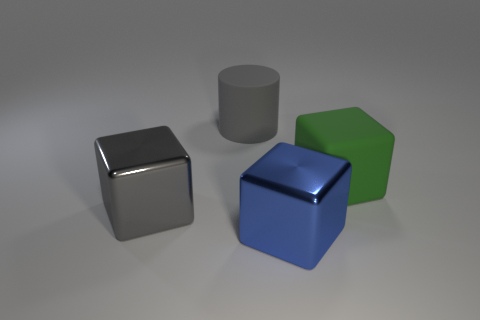There is a thing that is both behind the big blue shiny object and on the right side of the big matte cylinder; how big is it?
Offer a very short reply. Large. The big green rubber thing has what shape?
Provide a short and direct response. Cube. What number of objects are either green matte cylinders or shiny things that are on the right side of the big gray cylinder?
Offer a terse response. 1. Do the object that is behind the green thing and the large matte cube have the same color?
Provide a short and direct response. No. There is a object that is left of the big green matte thing and behind the gray block; what is its color?
Keep it short and to the point. Gray. There is a block that is right of the large blue object; what material is it?
Make the answer very short. Rubber. The blue block has what size?
Give a very brief answer. Large. How many purple objects are rubber cylinders or tiny metal balls?
Ensure brevity in your answer.  0. What size is the shiny thing that is on the right side of the big shiny thing that is behind the blue thing?
Your answer should be compact. Large. Do the big matte cylinder and the block that is to the right of the large blue metallic thing have the same color?
Offer a very short reply. No. 